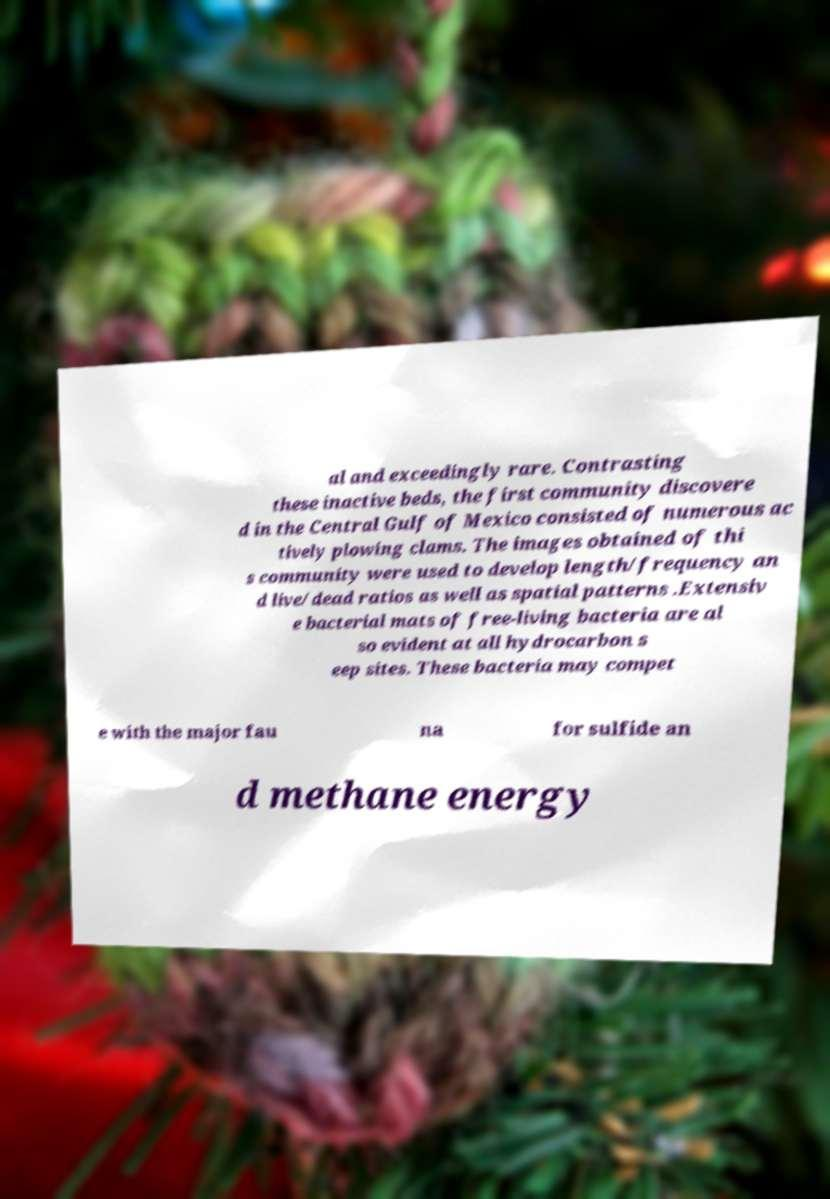There's text embedded in this image that I need extracted. Can you transcribe it verbatim? al and exceedingly rare. Contrasting these inactive beds, the first community discovere d in the Central Gulf of Mexico consisted of numerous ac tively plowing clams. The images obtained of thi s community were used to develop length/frequency an d live/dead ratios as well as spatial patterns .Extensiv e bacterial mats of free-living bacteria are al so evident at all hydrocarbon s eep sites. These bacteria may compet e with the major fau na for sulfide an d methane energy 